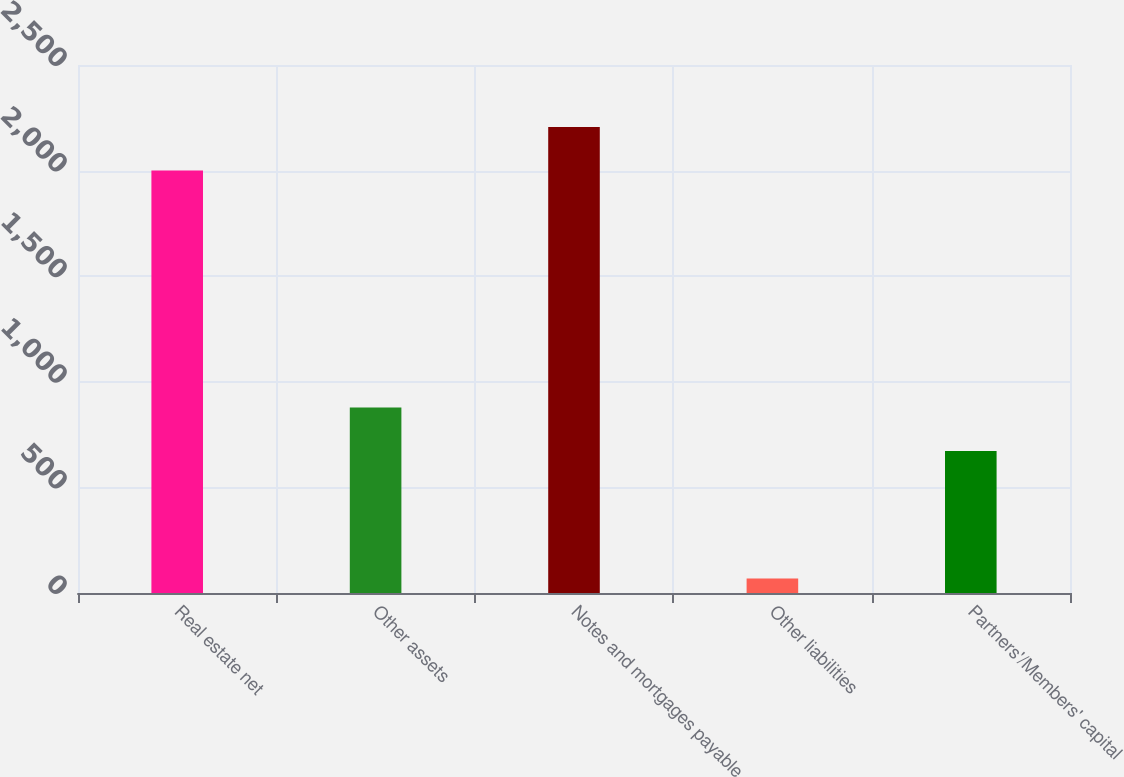<chart> <loc_0><loc_0><loc_500><loc_500><bar_chart><fcel>Real estate net<fcel>Other assets<fcel>Notes and mortgages payable<fcel>Other liabilities<fcel>Partners'/Members' capital<nl><fcel>2000.9<fcel>878.22<fcel>2206.22<fcel>68.1<fcel>672.9<nl></chart> 